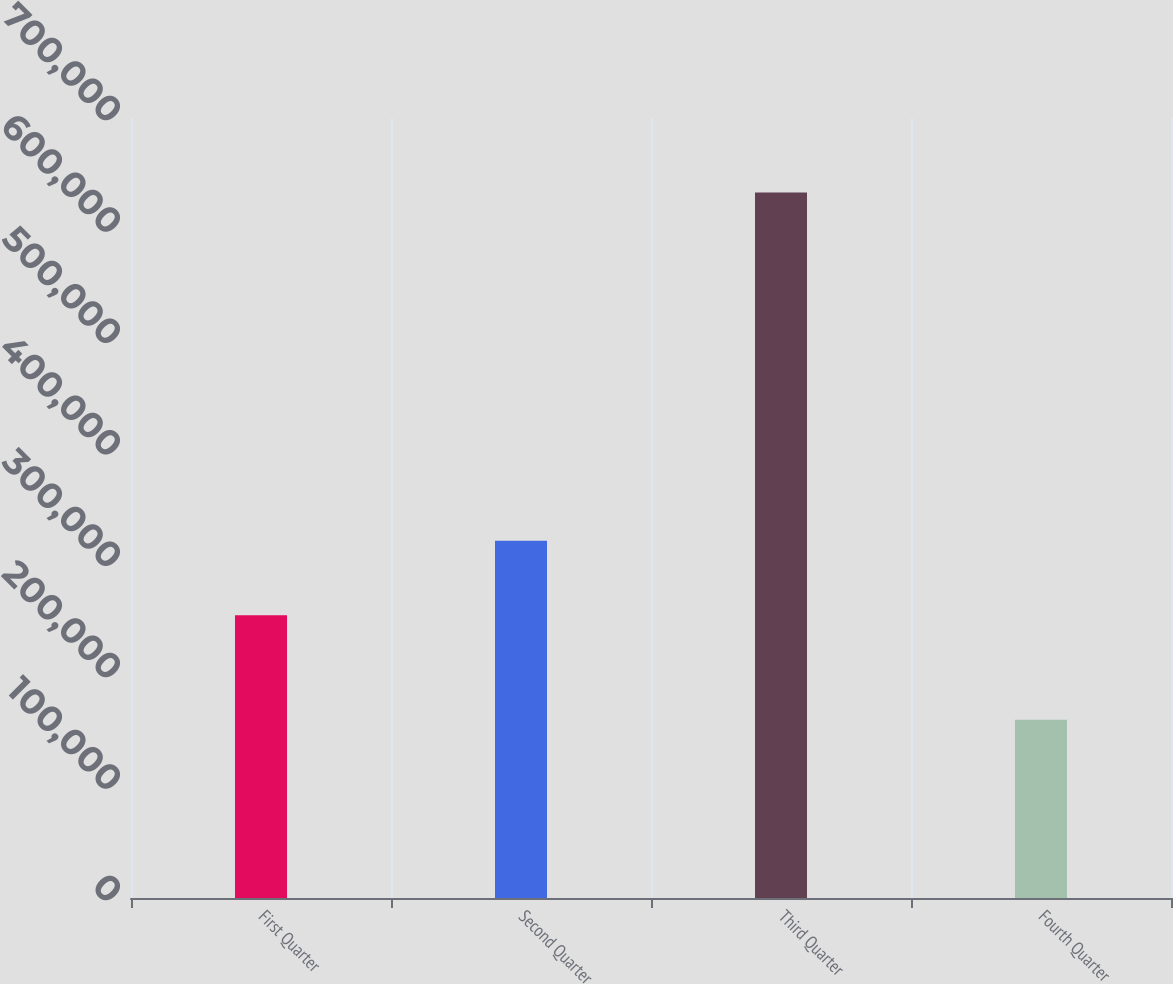Convert chart. <chart><loc_0><loc_0><loc_500><loc_500><bar_chart><fcel>First Quarter<fcel>Second Quarter<fcel>Third Quarter<fcel>Fourth Quarter<nl><fcel>253678<fcel>320598<fcel>633069<fcel>160027<nl></chart> 